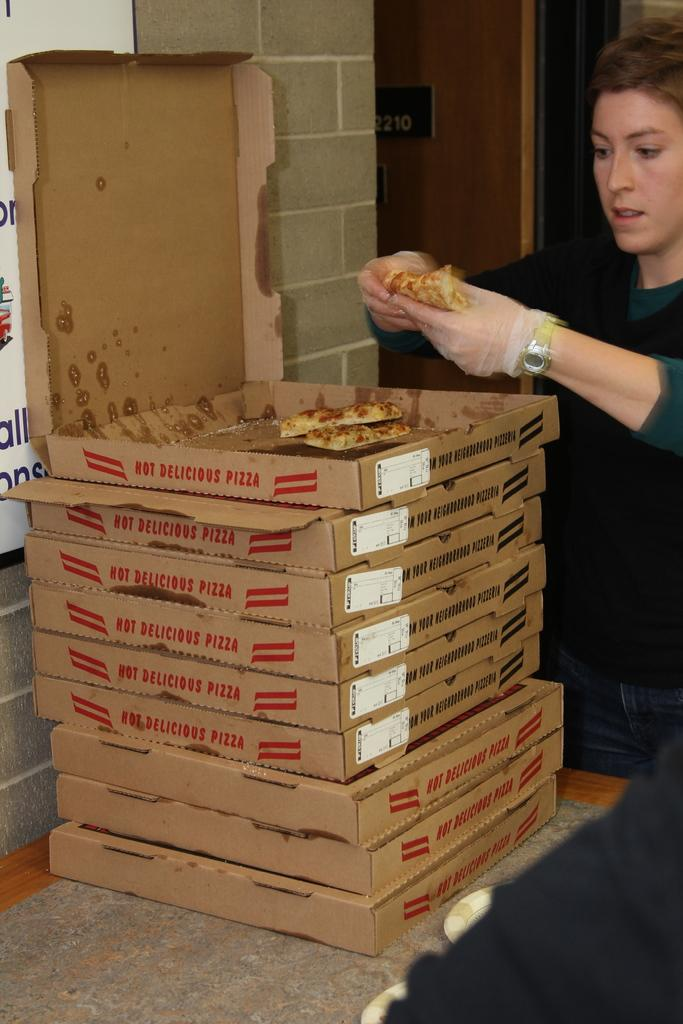Provide a one-sentence caption for the provided image. A woman takes a slice from the stack of HOT DELICIOUS PIZZA. 